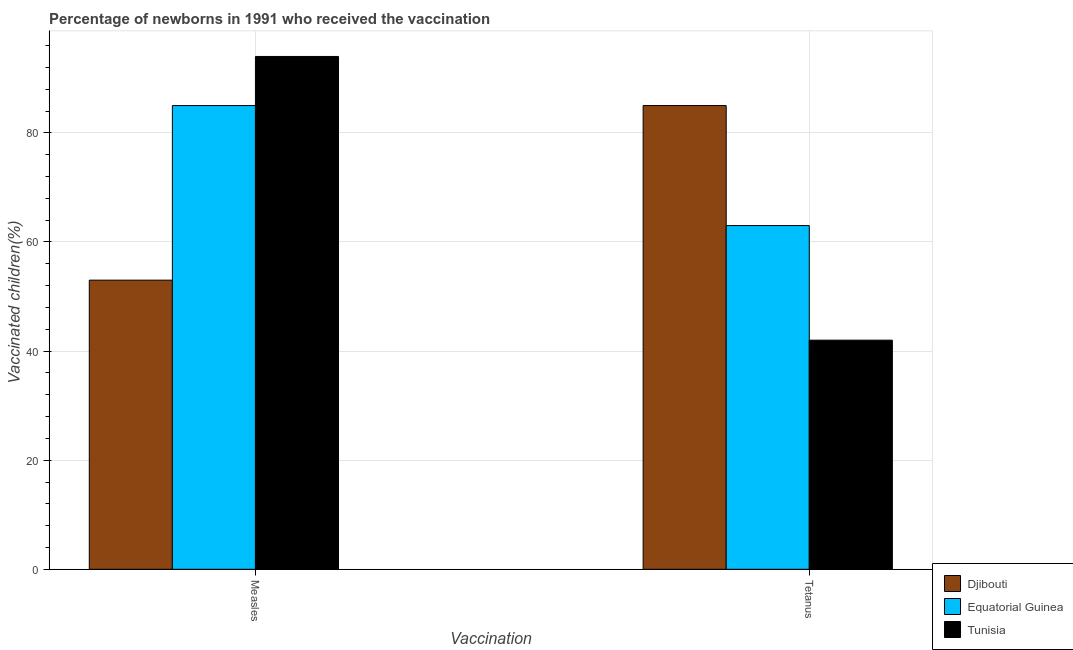How many groups of bars are there?
Your answer should be very brief. 2. Are the number of bars on each tick of the X-axis equal?
Offer a very short reply. Yes. How many bars are there on the 2nd tick from the left?
Make the answer very short. 3. What is the label of the 2nd group of bars from the left?
Offer a very short reply. Tetanus. What is the percentage of newborns who received vaccination for tetanus in Tunisia?
Provide a short and direct response. 42. Across all countries, what is the maximum percentage of newborns who received vaccination for tetanus?
Provide a succinct answer. 85. Across all countries, what is the minimum percentage of newborns who received vaccination for measles?
Give a very brief answer. 53. In which country was the percentage of newborns who received vaccination for tetanus maximum?
Give a very brief answer. Djibouti. In which country was the percentage of newborns who received vaccination for measles minimum?
Keep it short and to the point. Djibouti. What is the total percentage of newborns who received vaccination for measles in the graph?
Your answer should be very brief. 232. What is the difference between the percentage of newborns who received vaccination for measles in Equatorial Guinea and that in Tunisia?
Offer a terse response. -9. What is the difference between the percentage of newborns who received vaccination for measles in Tunisia and the percentage of newborns who received vaccination for tetanus in Djibouti?
Give a very brief answer. 9. What is the average percentage of newborns who received vaccination for measles per country?
Ensure brevity in your answer.  77.33. What is the difference between the percentage of newborns who received vaccination for measles and percentage of newborns who received vaccination for tetanus in Tunisia?
Offer a terse response. 52. What is the ratio of the percentage of newborns who received vaccination for tetanus in Tunisia to that in Equatorial Guinea?
Offer a very short reply. 0.67. Is the percentage of newborns who received vaccination for measles in Equatorial Guinea less than that in Djibouti?
Your answer should be compact. No. In how many countries, is the percentage of newborns who received vaccination for measles greater than the average percentage of newborns who received vaccination for measles taken over all countries?
Provide a short and direct response. 2. What does the 3rd bar from the left in Measles represents?
Make the answer very short. Tunisia. What does the 1st bar from the right in Measles represents?
Keep it short and to the point. Tunisia. Are the values on the major ticks of Y-axis written in scientific E-notation?
Offer a terse response. No. Does the graph contain grids?
Offer a very short reply. Yes. Where does the legend appear in the graph?
Offer a terse response. Bottom right. How are the legend labels stacked?
Your answer should be very brief. Vertical. What is the title of the graph?
Ensure brevity in your answer.  Percentage of newborns in 1991 who received the vaccination. Does "Bahamas" appear as one of the legend labels in the graph?
Your answer should be very brief. No. What is the label or title of the X-axis?
Keep it short and to the point. Vaccination. What is the label or title of the Y-axis?
Provide a succinct answer. Vaccinated children(%)
. What is the Vaccinated children(%)
 of Djibouti in Measles?
Your response must be concise. 53. What is the Vaccinated children(%)
 of Equatorial Guinea in Measles?
Provide a succinct answer. 85. What is the Vaccinated children(%)
 in Tunisia in Measles?
Your answer should be compact. 94. What is the Vaccinated children(%)
 of Djibouti in Tetanus?
Ensure brevity in your answer.  85. What is the Vaccinated children(%)
 in Tunisia in Tetanus?
Your answer should be very brief. 42. Across all Vaccination, what is the maximum Vaccinated children(%)
 of Djibouti?
Your answer should be very brief. 85. Across all Vaccination, what is the maximum Vaccinated children(%)
 in Equatorial Guinea?
Give a very brief answer. 85. Across all Vaccination, what is the maximum Vaccinated children(%)
 in Tunisia?
Offer a terse response. 94. Across all Vaccination, what is the minimum Vaccinated children(%)
 in Tunisia?
Ensure brevity in your answer.  42. What is the total Vaccinated children(%)
 in Djibouti in the graph?
Your response must be concise. 138. What is the total Vaccinated children(%)
 in Equatorial Guinea in the graph?
Your answer should be compact. 148. What is the total Vaccinated children(%)
 of Tunisia in the graph?
Ensure brevity in your answer.  136. What is the difference between the Vaccinated children(%)
 of Djibouti in Measles and that in Tetanus?
Your answer should be very brief. -32. What is the difference between the Vaccinated children(%)
 of Equatorial Guinea in Measles and that in Tetanus?
Your answer should be compact. 22. What is the difference between the Vaccinated children(%)
 of Tunisia in Measles and that in Tetanus?
Your answer should be compact. 52. What is the difference between the Vaccinated children(%)
 of Djibouti in Measles and the Vaccinated children(%)
 of Tunisia in Tetanus?
Give a very brief answer. 11. What is the average Vaccinated children(%)
 in Djibouti per Vaccination?
Provide a succinct answer. 69. What is the average Vaccinated children(%)
 in Equatorial Guinea per Vaccination?
Your answer should be compact. 74. What is the average Vaccinated children(%)
 of Tunisia per Vaccination?
Provide a succinct answer. 68. What is the difference between the Vaccinated children(%)
 of Djibouti and Vaccinated children(%)
 of Equatorial Guinea in Measles?
Provide a short and direct response. -32. What is the difference between the Vaccinated children(%)
 in Djibouti and Vaccinated children(%)
 in Tunisia in Measles?
Ensure brevity in your answer.  -41. What is the difference between the Vaccinated children(%)
 in Djibouti and Vaccinated children(%)
 in Equatorial Guinea in Tetanus?
Keep it short and to the point. 22. What is the ratio of the Vaccinated children(%)
 of Djibouti in Measles to that in Tetanus?
Give a very brief answer. 0.62. What is the ratio of the Vaccinated children(%)
 in Equatorial Guinea in Measles to that in Tetanus?
Make the answer very short. 1.35. What is the ratio of the Vaccinated children(%)
 of Tunisia in Measles to that in Tetanus?
Ensure brevity in your answer.  2.24. What is the difference between the highest and the second highest Vaccinated children(%)
 in Djibouti?
Provide a short and direct response. 32. What is the difference between the highest and the lowest Vaccinated children(%)
 in Equatorial Guinea?
Offer a very short reply. 22. What is the difference between the highest and the lowest Vaccinated children(%)
 of Tunisia?
Your answer should be compact. 52. 